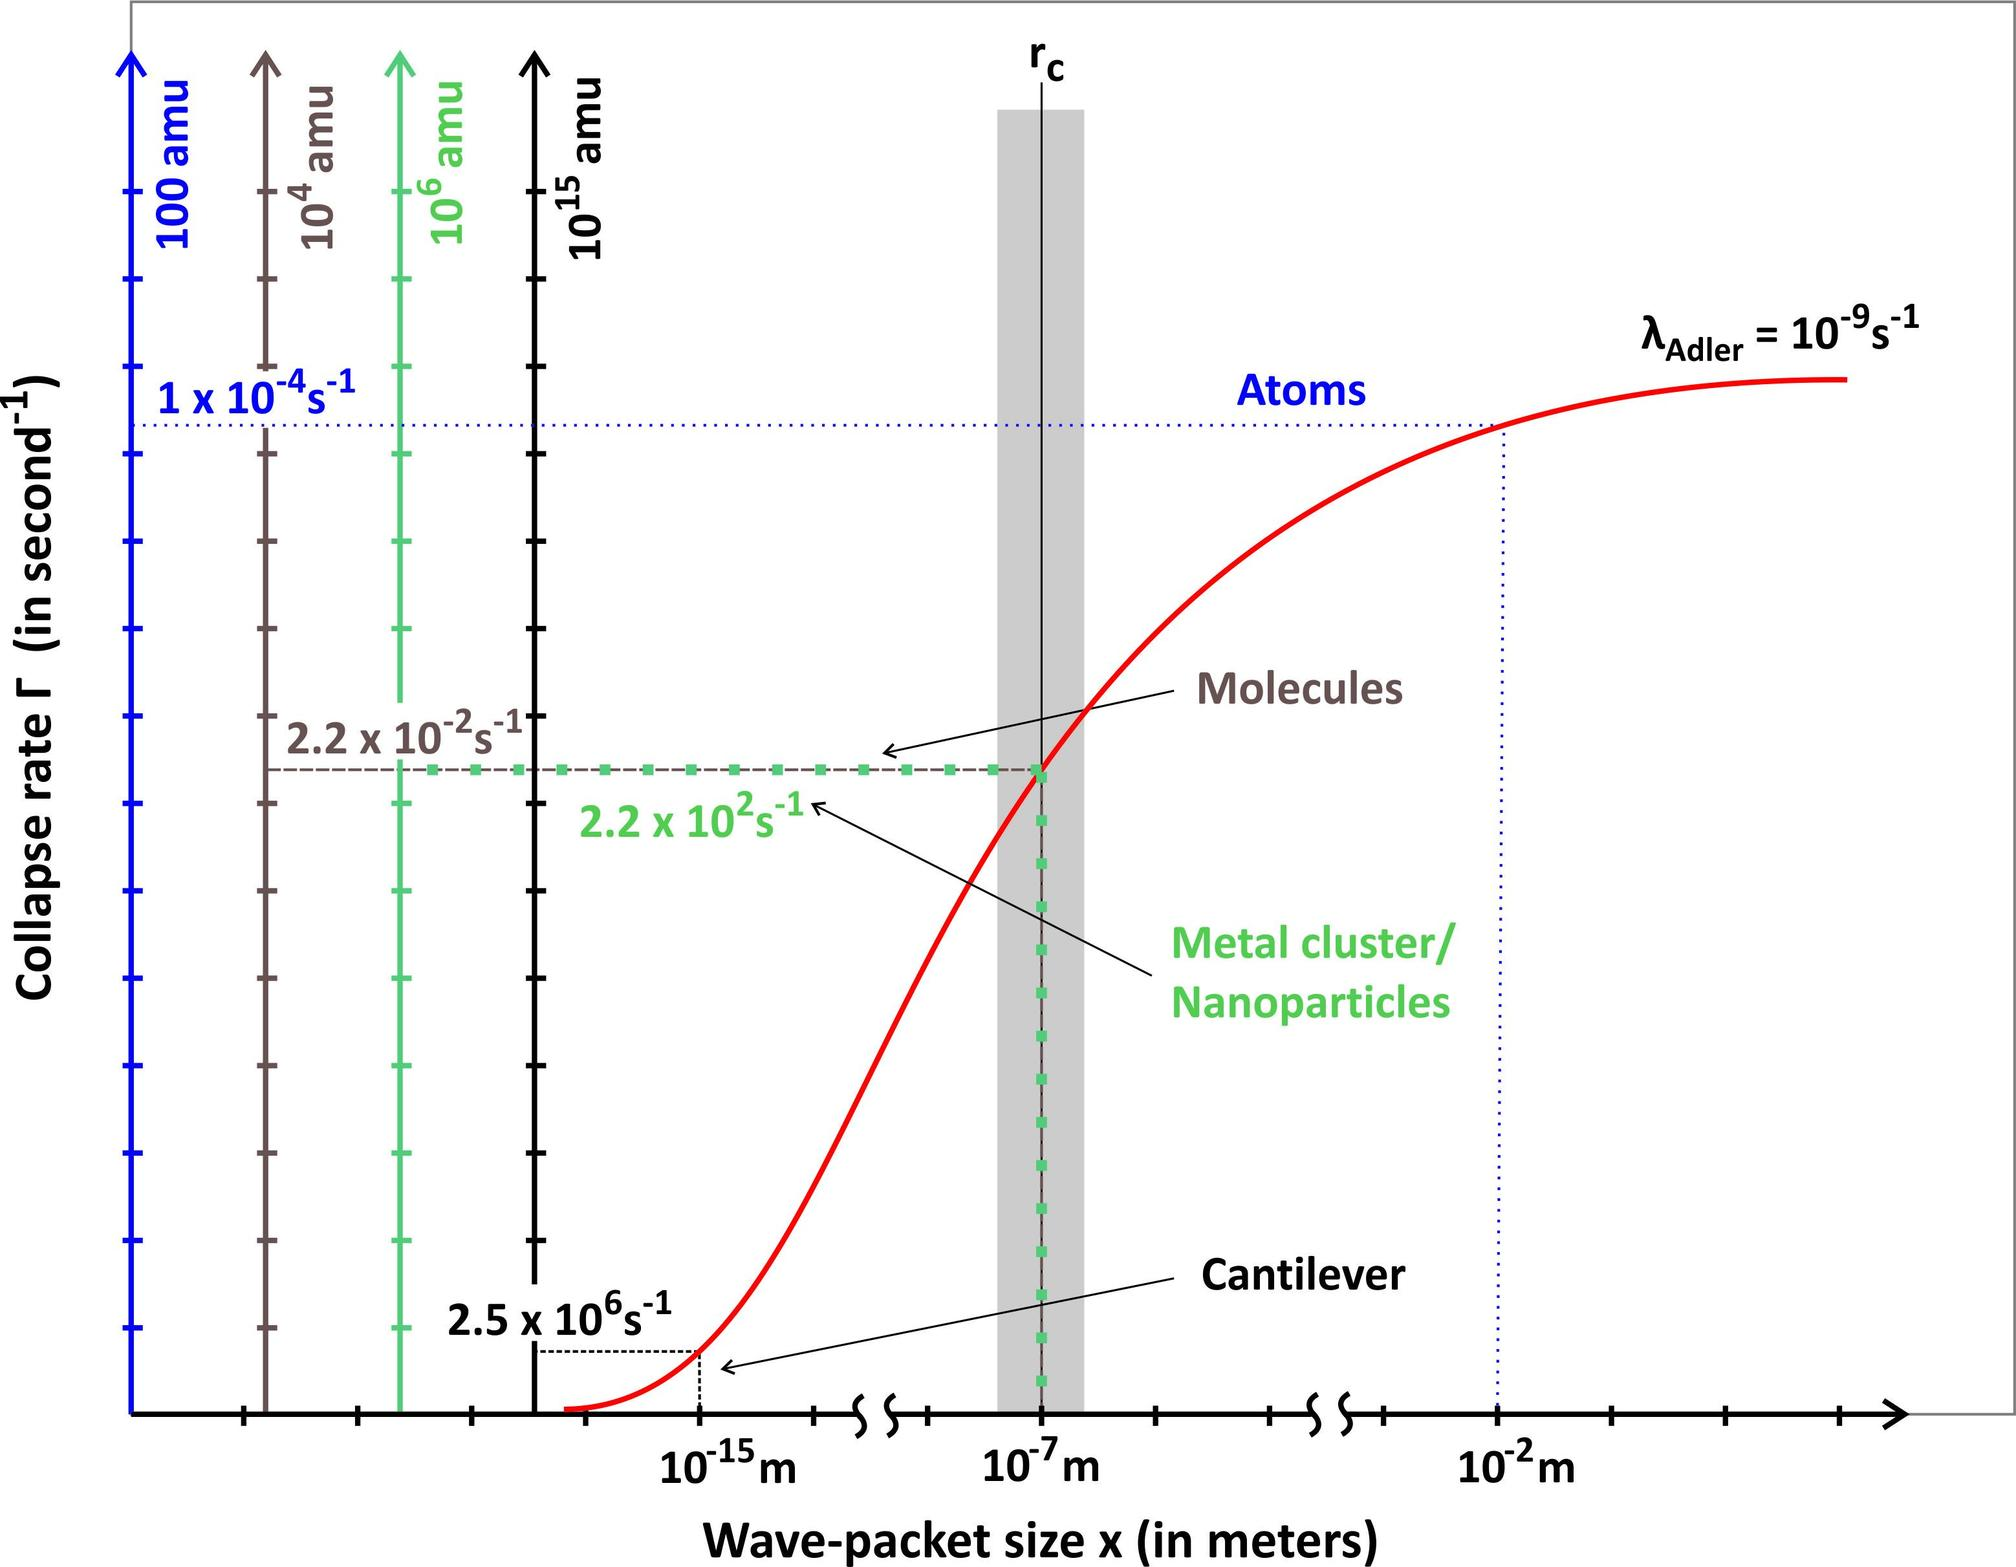What does the graph in the figure primarily illustrate? A. The relationship between temperature and gas solubility in liquids B. The effect of pressure on the boiling point of water C. The phase changes of water at different temperatures and pressures D. The comparison of thermal conductivity in various metals The graph depicts a phase diagram, which typically shows the states of a substance (like water) at various temperatures and pressures. The lines represent phase boundaries (solid, liquid, and gas), making option C the correct choice, as it directly refers to phase changes at different temperatures and pressures. Therefore, the correct answer is C. 